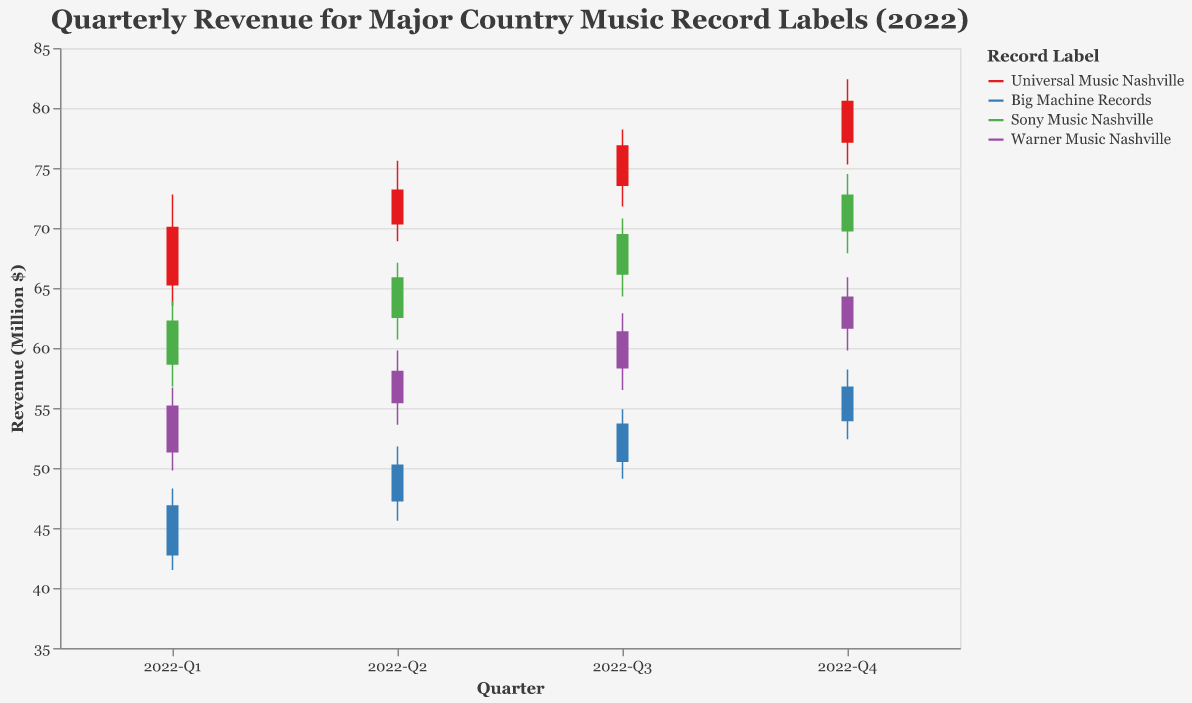What is the title of the figure? The title is shown at the top of the figure. It reads "Quarterly Revenue for Major Country Music Record Labels (2022)".
Answer: Quarterly Revenue for Major Country Music Record Labels (2022) What does the y-axis represent? The label on the y-axis indicates it represents "Revenue (Million $)".
Answer: Revenue (Million $) How many record labels are shown in the figure? The color legend lists the number of distinct record labels. There are four: Universal Music Nashville, Big Machine Records, Sony Music Nashville, and Warner Music Nashville.
Answer: Four Which record label had the highest closing revenue in 2022-Q1? Look at the 2022-Q1 section for each record label and identify the highest closing value. Universal Music Nashville has the highest closing revenue with 70.1 million dollars.
Answer: Universal Music Nashville Compare the closing revenue of Big Machine Records in 2022-Q1 and 2022-Q4. Which quarter had the higher closing value? Check the closing values for Big Machine Records in both quarters. In 2022-Q1 it was 46.9 million dollars, and in 2022-Q4 it was 56.8 million dollars.
Answer: 2022-Q4 What was the lowest revenue recorded by Sony Music Nashville in 2022-Q2? Look for the lowest value in the 2022-Q2 section for Sony Music Nashville. It was 60.7 million dollars.
Answer: 60.7 million dollars Between Warner Music Nashville and Sony Music Nashville, which had a higher high value in 2022-Q3? Compare the high values for 2022-Q3 of both labels. Warner Music Nashville had a high of 62.9 million dollars, while Sony Music Nashville had 70.8 million dollars.
Answer: Sony Music Nashville What was the revenue range for Universal Music Nashville in 2022-Q3? The range is calculated by subtracting the lowest value from the highest value. For Universal Music Nashville in 2022-Q3, it is 78.2 - 71.8 = 6.4 million dollars.
Answer: 6.4 million dollars Calculate the average closing revenue for Universal Music Nashville over all four quarters. Add the closing values for Universal Music Nashville and divide by 4. (70.1 + 73.2 + 76.9 + 80.6) / 4 = 75.2 million dollars.
Answer: 75.2 million dollars 